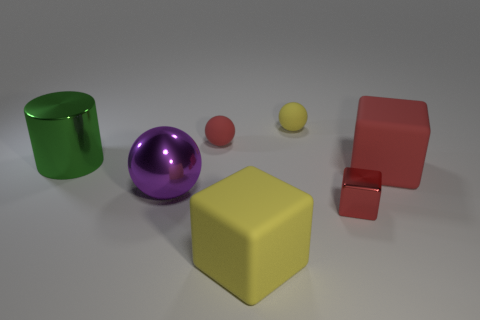Subtract all large balls. How many balls are left? 2 Subtract all blue cylinders. How many red cubes are left? 2 Add 1 blocks. How many objects exist? 8 Subtract all balls. How many objects are left? 4 Subtract all blue blocks. Subtract all yellow balls. How many blocks are left? 3 Subtract all tiny brown metal balls. Subtract all metallic balls. How many objects are left? 6 Add 3 green cylinders. How many green cylinders are left? 4 Add 4 yellow rubber things. How many yellow rubber things exist? 6 Subtract 0 cyan spheres. How many objects are left? 7 